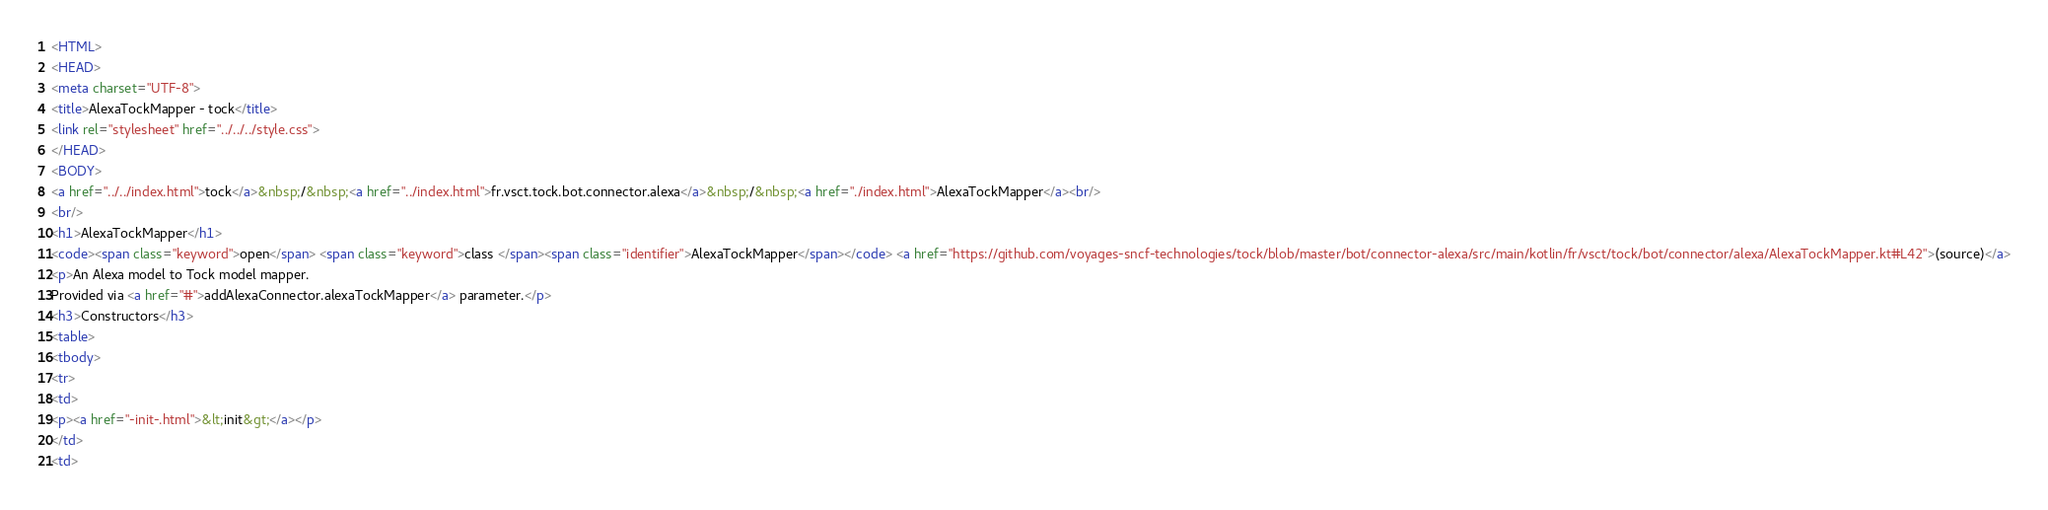<code> <loc_0><loc_0><loc_500><loc_500><_HTML_><HTML>
<HEAD>
<meta charset="UTF-8">
<title>AlexaTockMapper - tock</title>
<link rel="stylesheet" href="../../../style.css">
</HEAD>
<BODY>
<a href="../../index.html">tock</a>&nbsp;/&nbsp;<a href="../index.html">fr.vsct.tock.bot.connector.alexa</a>&nbsp;/&nbsp;<a href="./index.html">AlexaTockMapper</a><br/>
<br/>
<h1>AlexaTockMapper</h1>
<code><span class="keyword">open</span> <span class="keyword">class </span><span class="identifier">AlexaTockMapper</span></code> <a href="https://github.com/voyages-sncf-technologies/tock/blob/master/bot/connector-alexa/src/main/kotlin/fr/vsct/tock/bot/connector/alexa/AlexaTockMapper.kt#L42">(source)</a>
<p>An Alexa model to Tock model mapper.
Provided via <a href="#">addAlexaConnector.alexaTockMapper</a> parameter.</p>
<h3>Constructors</h3>
<table>
<tbody>
<tr>
<td>
<p><a href="-init-.html">&lt;init&gt;</a></p>
</td>
<td></code> 